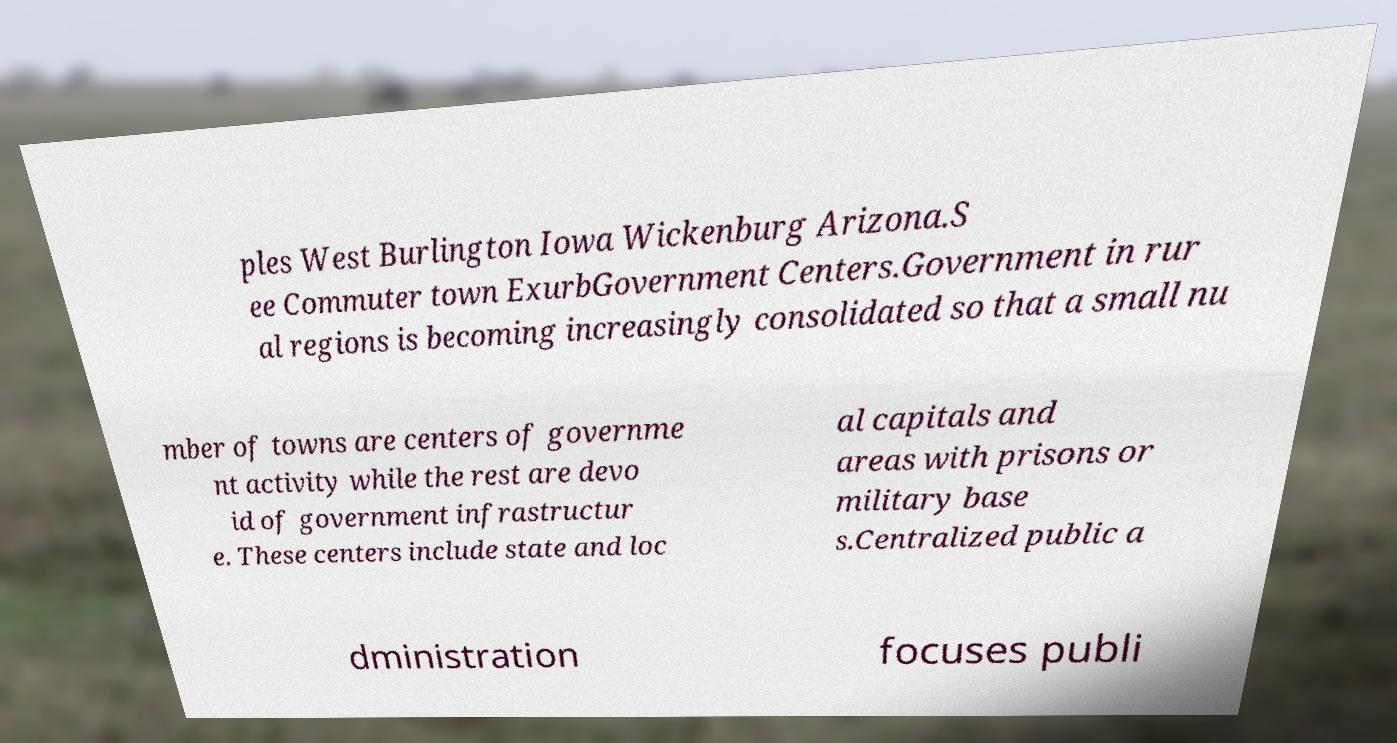Can you accurately transcribe the text from the provided image for me? ples West Burlington Iowa Wickenburg Arizona.S ee Commuter town ExurbGovernment Centers.Government in rur al regions is becoming increasingly consolidated so that a small nu mber of towns are centers of governme nt activity while the rest are devo id of government infrastructur e. These centers include state and loc al capitals and areas with prisons or military base s.Centralized public a dministration focuses publi 